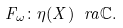Convert formula to latex. <formula><loc_0><loc_0><loc_500><loc_500>F _ { \omega } \colon \eta ( X ) \ r a \mathbb { C } .</formula> 